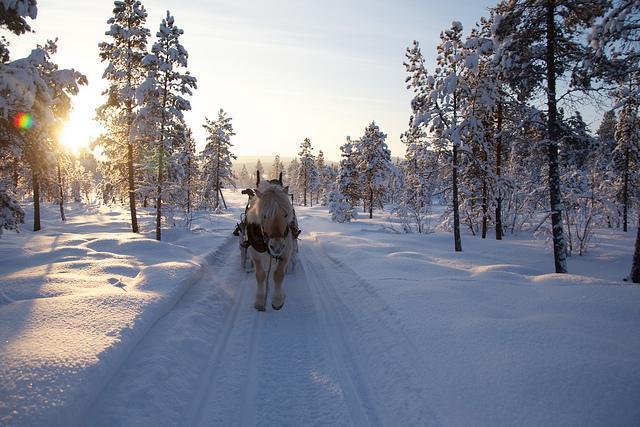How many horses are visible?
Give a very brief answer. 1. 